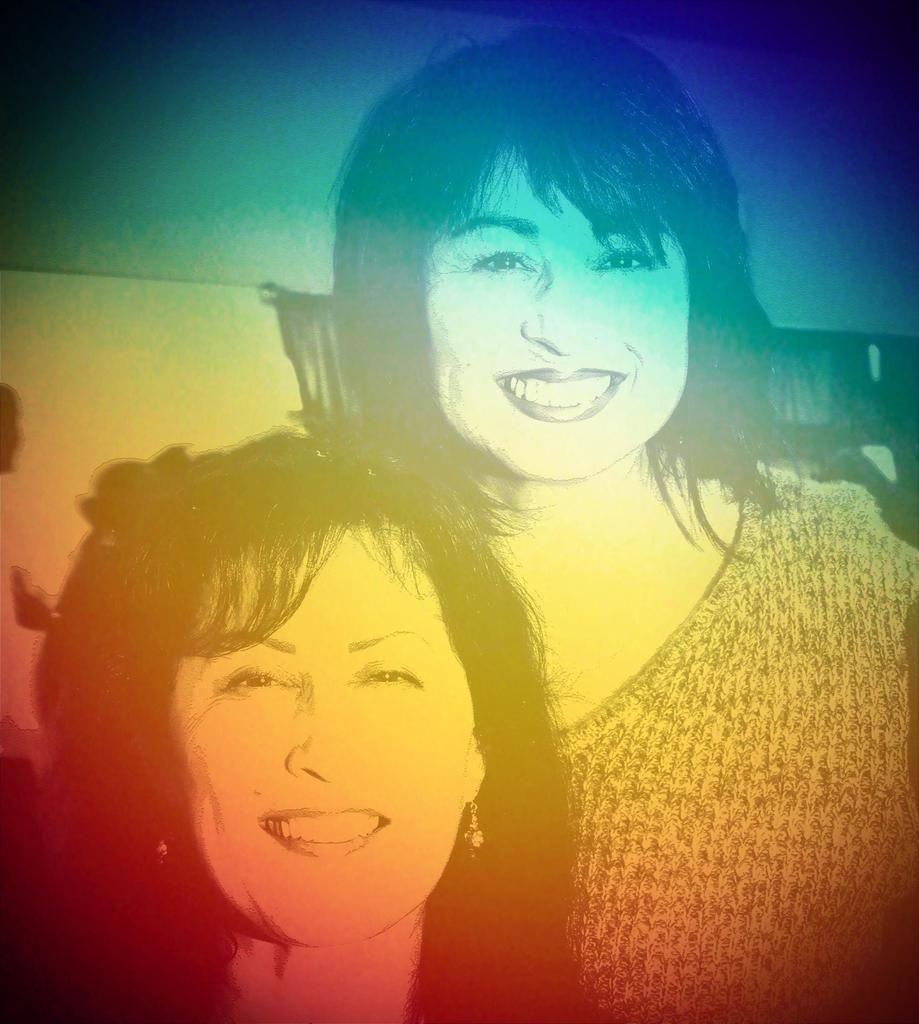How many people are in the image? There are two women in the picture. What is the facial expression of the women in the image? The women are smiling. What type of toothpaste is the woman on the left using in the image? There is no toothpaste present in the image, as it features two women smiling. Can you see a hill in the background of the image? There is no hill visible in the image; it only shows two women smiling. 